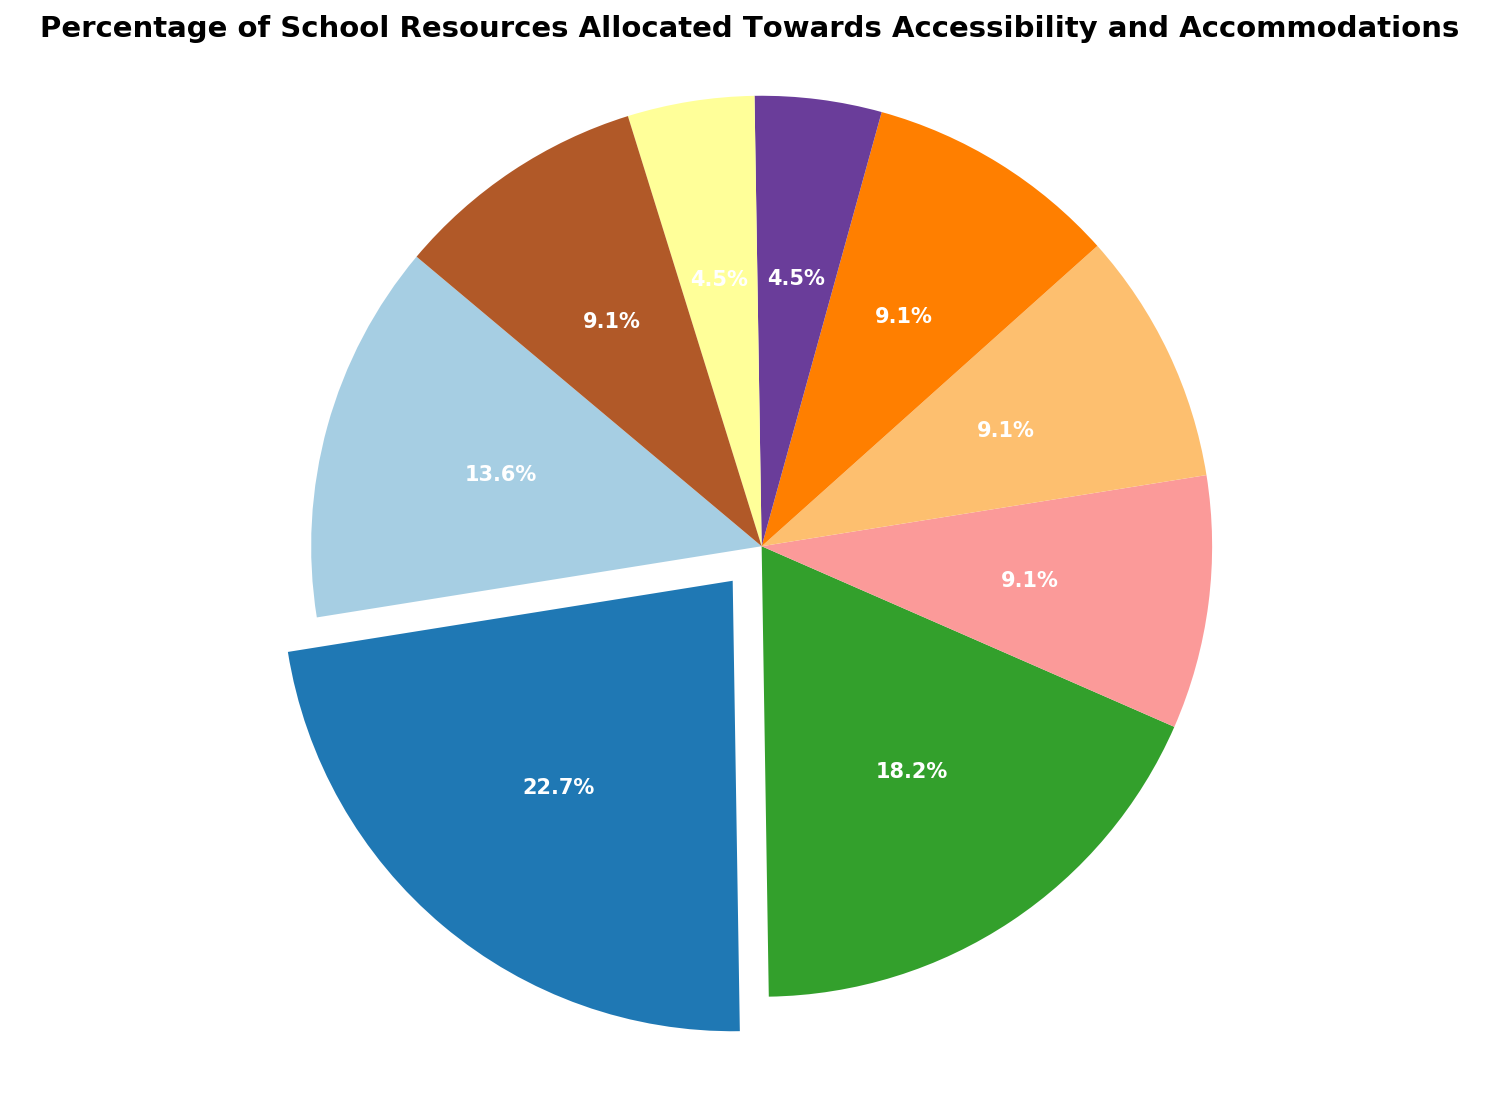What's the percentage of resources allocated towards Special Education Support? The pie chart shows the allocation of resources. Locate the section titled "Special Education Support" and observe the percentage shown in that segment.
Answer: 25% Which two categories have the smallest allocation of resources? Identify the segments of the pie chart with the smallest percentages. The two smallest segments are "Sensory-Friendly Spaces" and "Staff Training on Disabilities," each with 5%.
Answer: Sensory-Friendly Spaces and Staff Training on Disabilities What percentage of resources is allocated to Assistive Technologies and Accessible Transportation combined? Add the percentages from the segments labeled "Assistive Technologies" (20%) and "Accessible Transportation" (10%). The combination is 20% + 10%.
Answer: 30% Which category has the highest resource allocation and by how much more is it than Modified Curricula? Identify the segment with the highest percentage, "Special Education Support" at 25%. Then, locate "Modified Curricula" at 10%. Subtract to find the difference: 25% - 10%.
Answer: Special Education Support; 15% What is the total percentage of resources allocated towards healthcare-related categories (Healthcare Facilities and Other Accessibility Services)? Identify and sum the percentages of "Healthcare Facilities" (10%) and "Other Accessibility Services" (10%). The sum is 10% + 10%.
Answer: 20% Which category is represented by the exploded segment of the pie chart? The pie segment that is slightly separated (exploded) indicates the largest category. The "Special Education Support" segment is exploded, and has the highest percentage (25%).
Answer: Special Education Support How much larger is the allocation for Accessibility Ramps compared to Sensory-Friendly Spaces? Identify the percentages for "Accessibility Ramps" (15%) and "Sensory-Friendly Spaces" (5%). Calculate the difference: 15% - 5%.
Answer: 10% Among the components that have a 10% allocation, what are they? Locate the segments of the pie chart that show 10%. These segments are "Modified Curricula," "Accessible Transportation," "Healthcare Facilities," and "Other Accessibility Services."
Answer: Modified Curricula, Accessible Transportation, Healthcare Facilities, Other Accessibility Services What is the average percentage of resources allocated to categories with percentages less than 15%? Identify the segments with percentages under 15%: "Modified Curricula" (10%), "Accessible Transportation" (10%), "Healthcare Facilities" (10%), "Sensory-Friendly Spaces" (5%), "Staff Training on Disabilities" (5%), and "Other Accessibility Services" (10%). Calculate the total (10% + 10% + 10% + 5% + 5% + 10%) and divide by the number of segments (6): (10 + 10 + 10 + 5 + 5 + 10) / 6.
Answer: 8.33% 